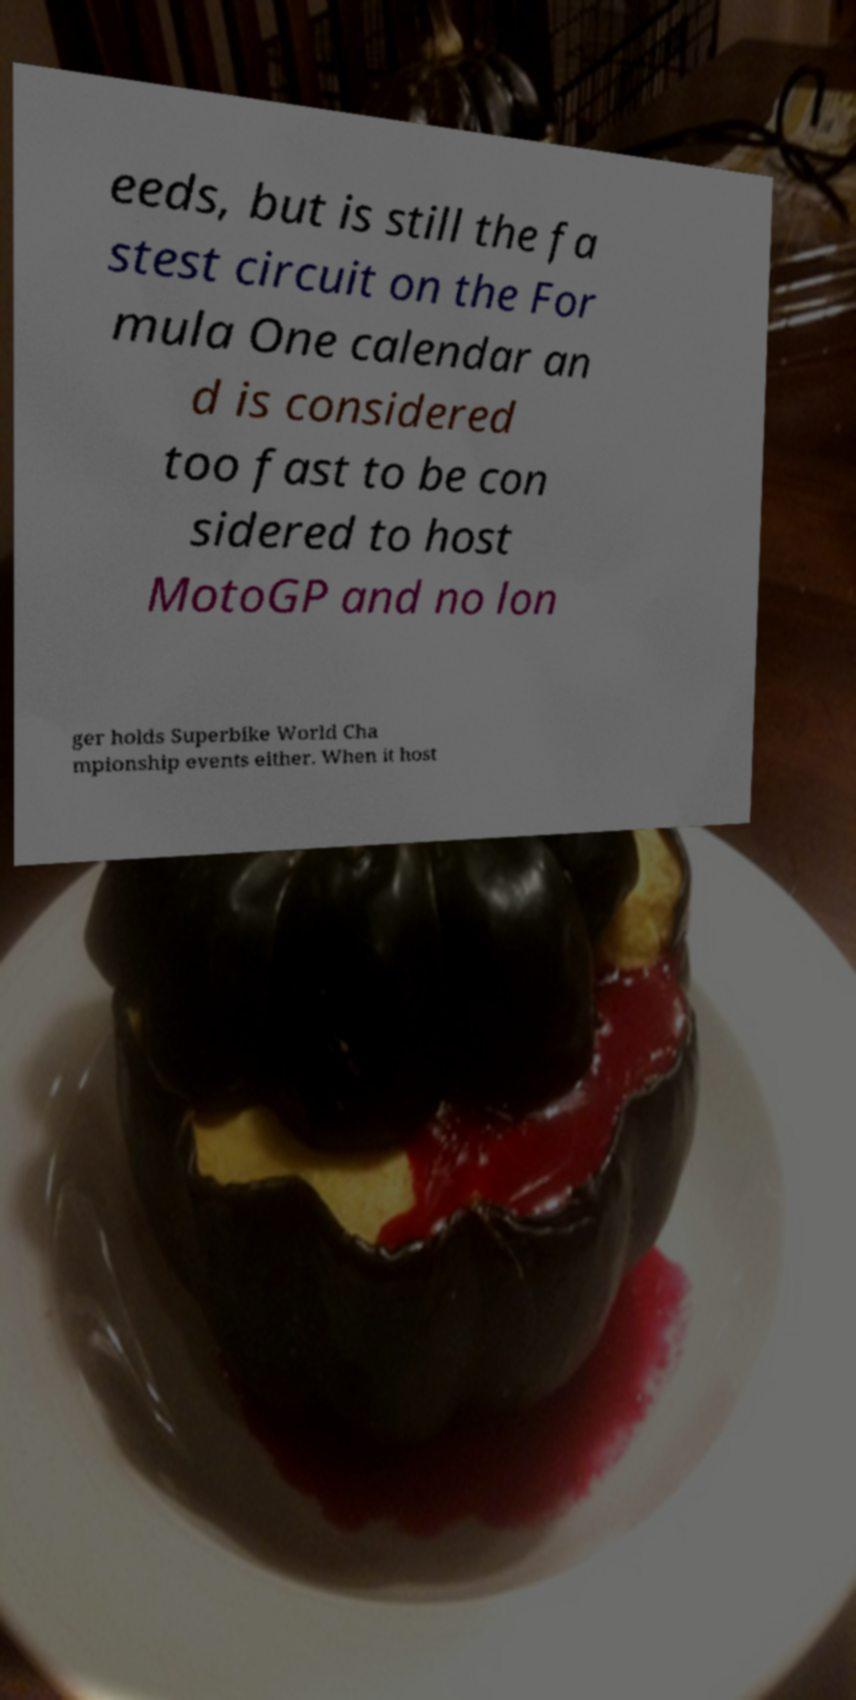Can you accurately transcribe the text from the provided image for me? eeds, but is still the fa stest circuit on the For mula One calendar an d is considered too fast to be con sidered to host MotoGP and no lon ger holds Superbike World Cha mpionship events either. When it host 